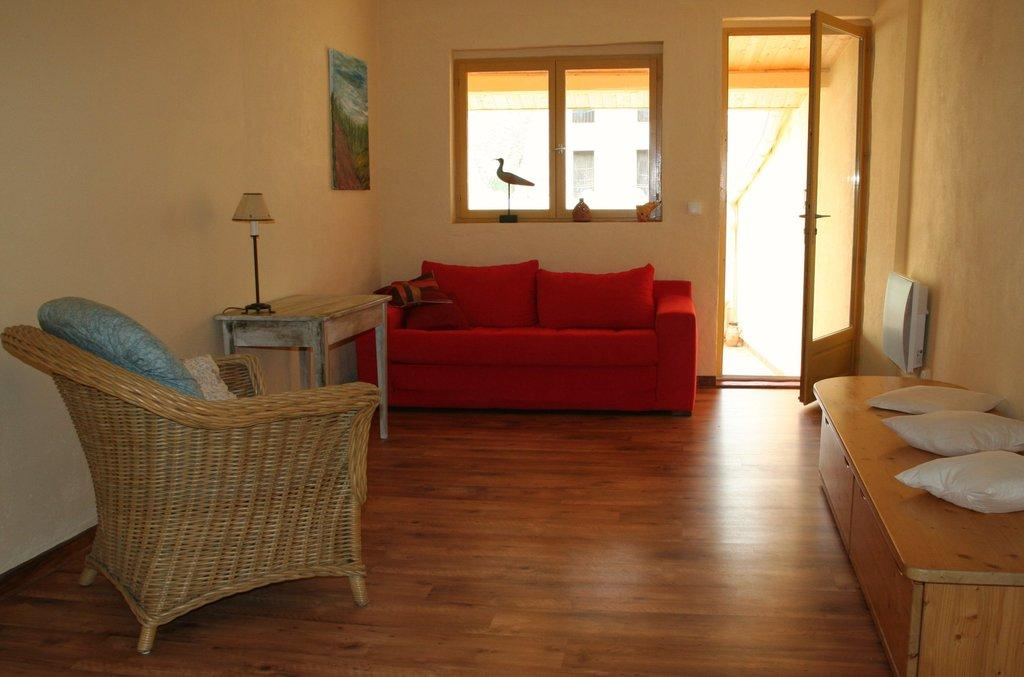What type of furniture is present in the image? There is a sofa, a table, and a chair in the image. What can be seen in the background of the image? There is a window, a door, and a frame on the wall in the background of the image. Can you describe the layout of the room in the image? The room appears to have a sofa, table, and chair, with a window and door visible in the background. What date is marked on the calendar in the image? There is no calendar present in the image. Can you tell me how many pets are visible in the image? There are no pets visible in the image. 